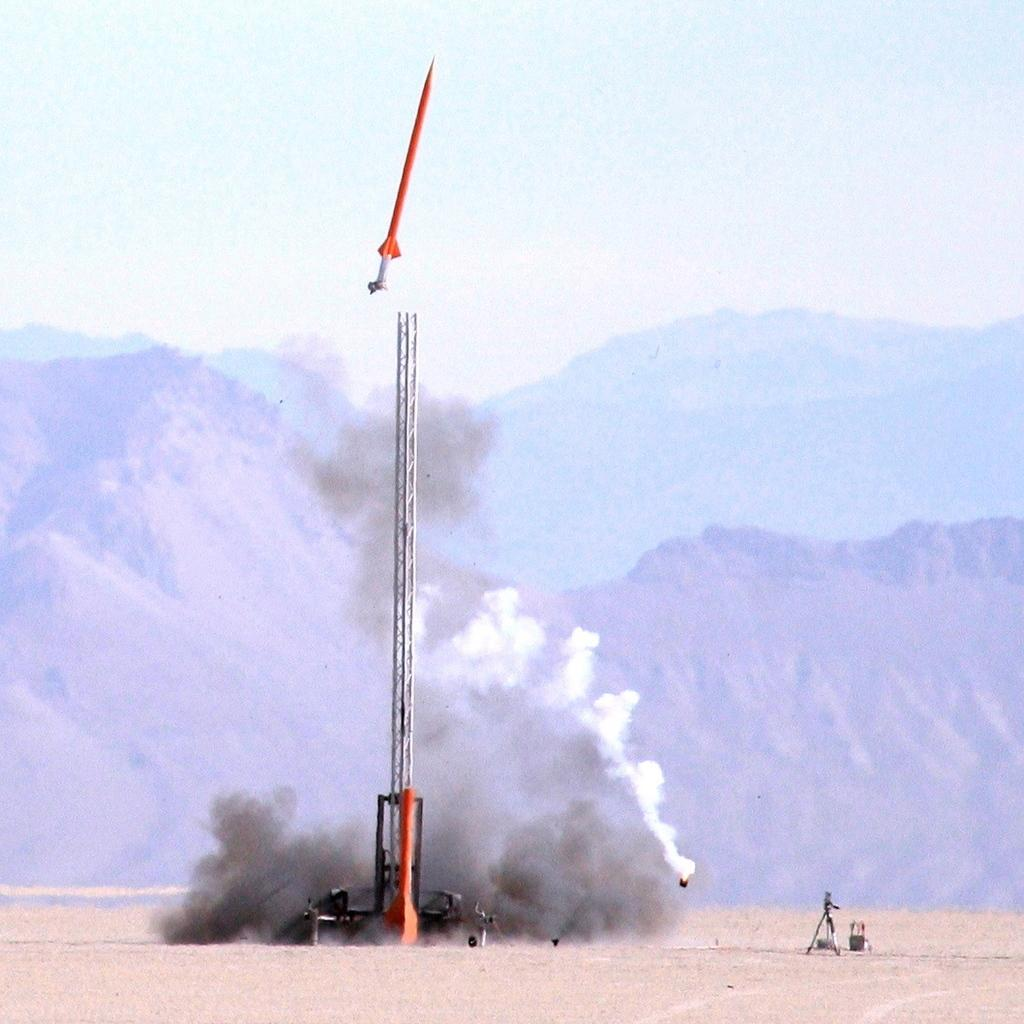What can be seen in the background of the image? There is sky and hills visible in the background of the image. What is present on the ground in the image? There are objects on the ground in the image. Can you describe the object in the air in the image? There is an object in the air in the image, but we cannot determine its specific characteristics from the provided facts. What is the nature of the smoke in the image? Smoke is present in the image, but we cannot determine its source or purpose from the provided facts. How many children are present in the image? There is no mention of children in the provided facts, so we cannot determine their presence in the image. What type of approval is being sought in the image? There is no indication of any approval process or request in the image, so we cannot determine its presence. 